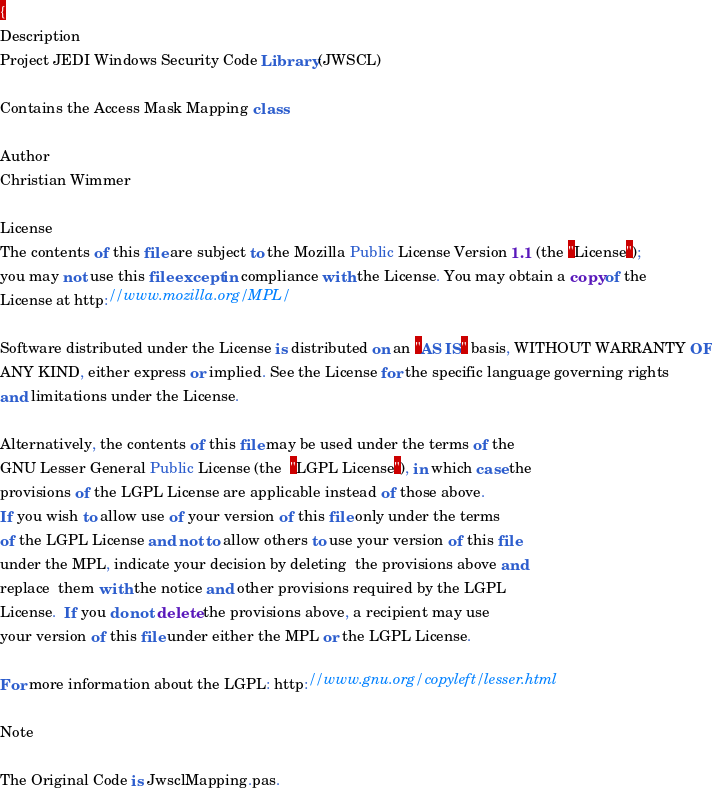<code> <loc_0><loc_0><loc_500><loc_500><_Pascal_>{
Description
Project JEDI Windows Security Code Library (JWSCL)

Contains the Access Mask Mapping class

Author
Christian Wimmer

License
The contents of this file are subject to the Mozilla Public License Version 1.1 (the "License");
you may not use this file except in compliance with the License. You may obtain a copy of the
License at http://www.mozilla.org/MPL/

Software distributed under the License is distributed on an "AS IS" basis, WITHOUT WARRANTY OF
ANY KIND, either express or implied. See the License for the specific language governing rights
and limitations under the License.

Alternatively, the contents of this file may be used under the terms of the  
GNU Lesser General Public License (the  "LGPL License"), in which case the   
provisions of the LGPL License are applicable instead of those above.        
If you wish to allow use of your version of this file only under the terms   
of the LGPL License and not to allow others to use your version of this file 
under the MPL, indicate your decision by deleting  the provisions above and
replace  them with the notice and other provisions required by the LGPL
License.  If you do not delete the provisions above, a recipient may use
your version of this file under either the MPL or the LGPL License.

For more information about the LGPL: http://www.gnu.org/copyleft/lesser.html

Note

The Original Code is JwsclMapping.pas.
</code> 